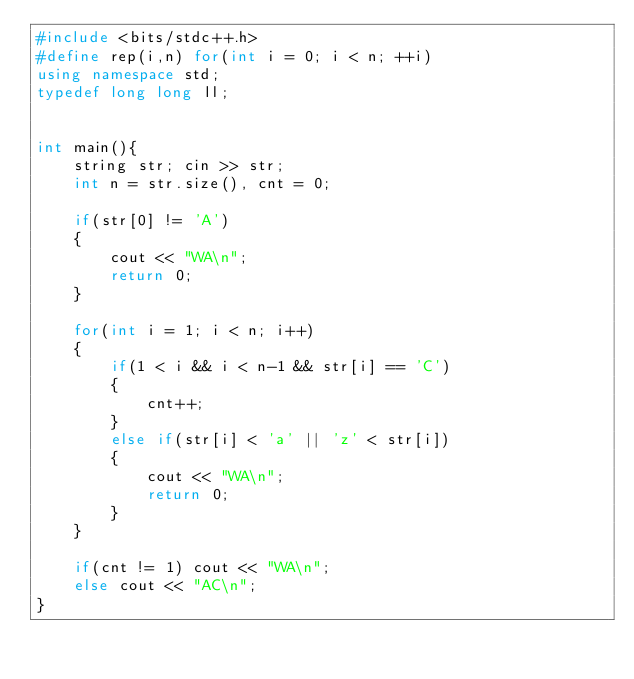<code> <loc_0><loc_0><loc_500><loc_500><_C++_>#include <bits/stdc++.h>
#define rep(i,n) for(int i = 0; i < n; ++i)
using namespace std;
typedef long long ll;


int main(){
    string str; cin >> str;
    int n = str.size(), cnt = 0;

    if(str[0] != 'A')
    {
        cout << "WA\n";
        return 0;
    }

    for(int i = 1; i < n; i++)
    {
        if(1 < i && i < n-1 && str[i] == 'C')
        {
            cnt++;
        }
        else if(str[i] < 'a' || 'z' < str[i])
        {
            cout << "WA\n";
            return 0;
        }
    }

    if(cnt != 1) cout << "WA\n";
    else cout << "AC\n";
}
</code> 